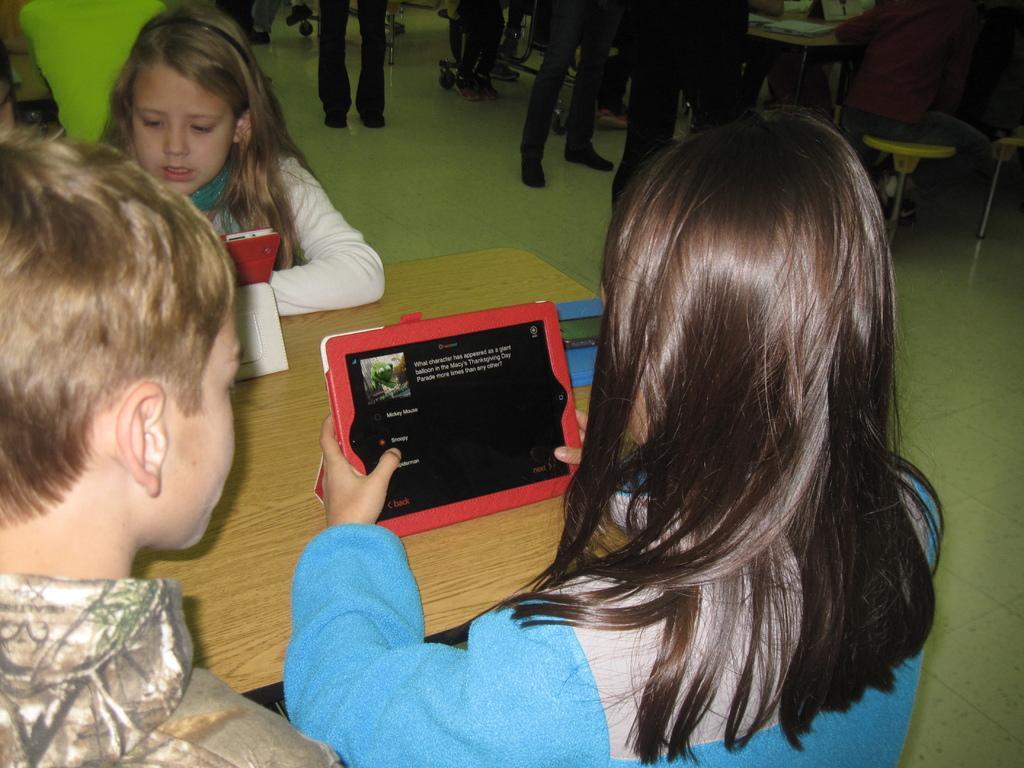Can you describe this image briefly? Here I can see three children are sitting around the table. The girl who is on the right side is holding a device in the hands. On the table there are few objects. At the top of the image I can see some more people standing and also there are some tables. 